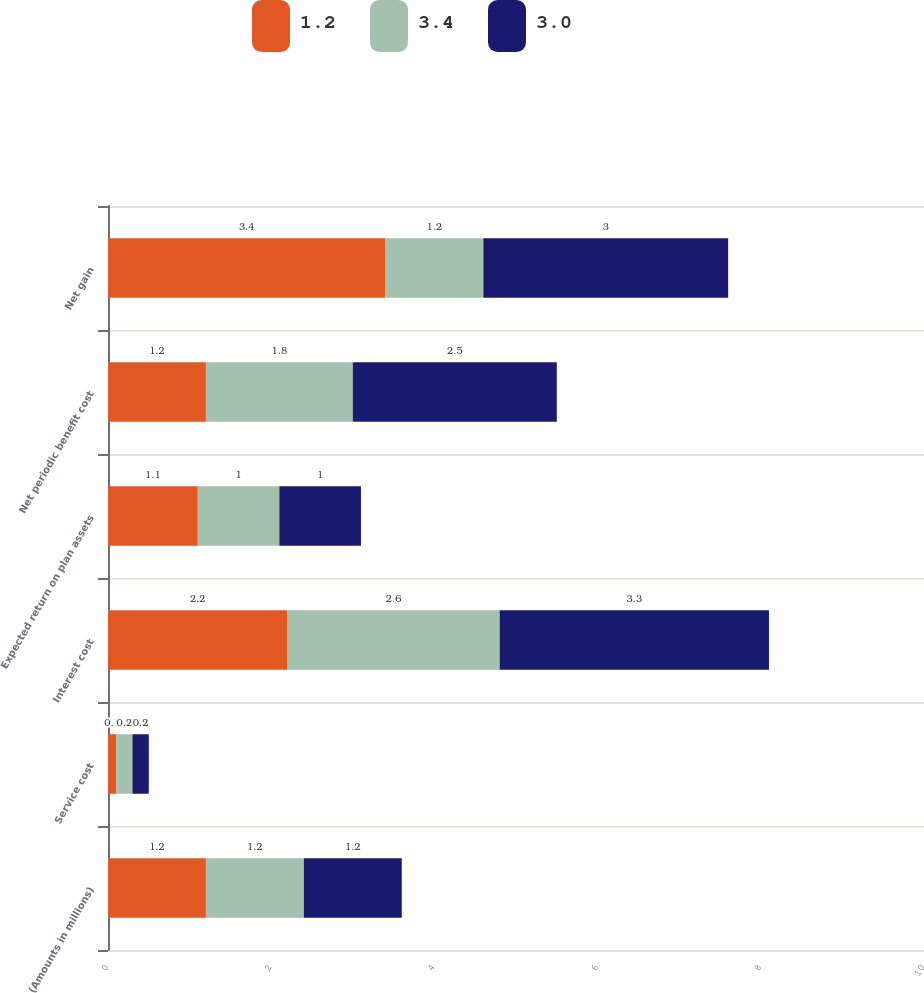Convert chart. <chart><loc_0><loc_0><loc_500><loc_500><stacked_bar_chart><ecel><fcel>(Amounts in millions)<fcel>Service cost<fcel>Interest cost<fcel>Expected return on plan assets<fcel>Net periodic benefit cost<fcel>Net gain<nl><fcel>1.2<fcel>1.2<fcel>0.1<fcel>2.2<fcel>1.1<fcel>1.2<fcel>3.4<nl><fcel>3.4<fcel>1.2<fcel>0.2<fcel>2.6<fcel>1<fcel>1.8<fcel>1.2<nl><fcel>3<fcel>1.2<fcel>0.2<fcel>3.3<fcel>1<fcel>2.5<fcel>3<nl></chart> 